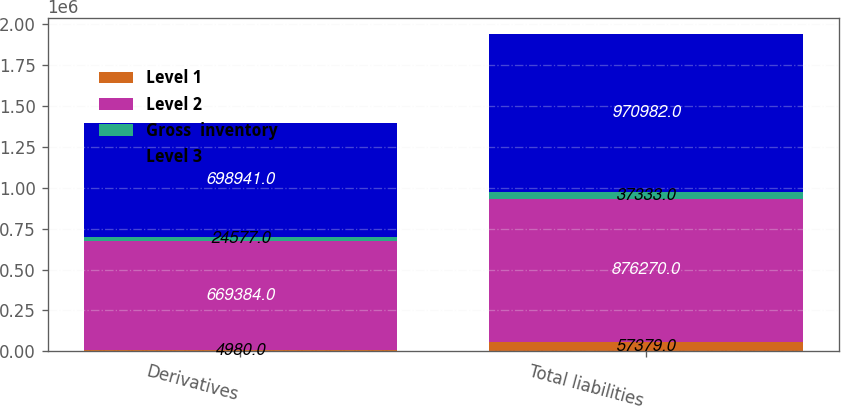<chart> <loc_0><loc_0><loc_500><loc_500><stacked_bar_chart><ecel><fcel>Derivatives<fcel>Total liabilities<nl><fcel>Level 1<fcel>4980<fcel>57379<nl><fcel>Level 2<fcel>669384<fcel>876270<nl><fcel>Gross  inventory<fcel>24577<fcel>37333<nl><fcel>Level 3<fcel>698941<fcel>970982<nl></chart> 